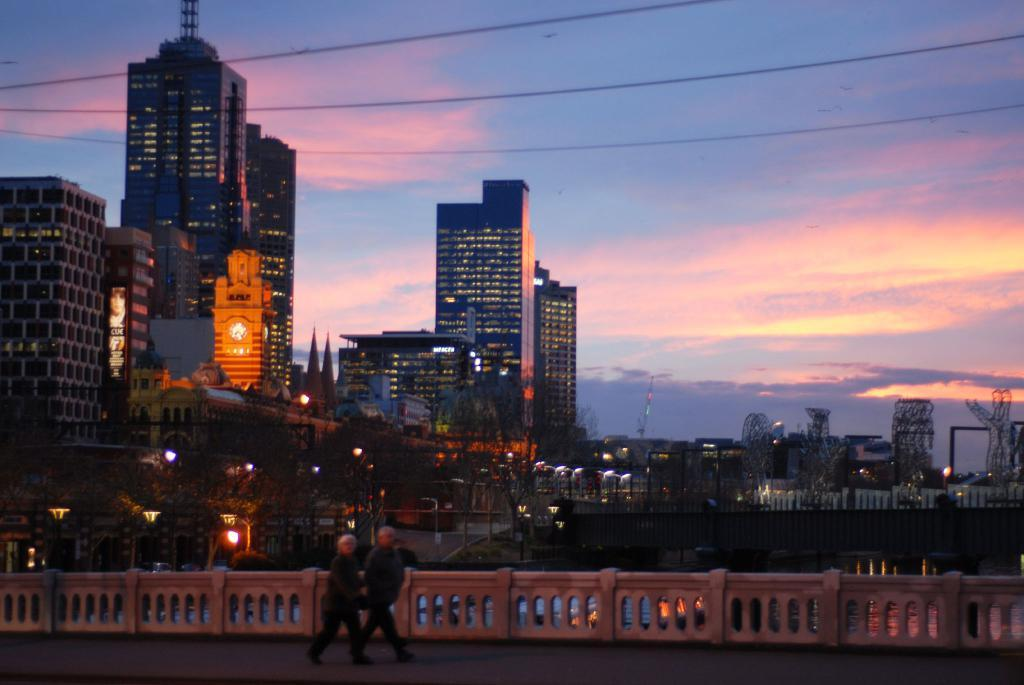What are the two people in the image doing? The two people in the image are walking. Where are they walking? They are walking on a path. What can be seen on the sides of the path? There is fencing from left to right in the image. What structures are visible in the image? There are buildings visible in the image. What is present in the image that might provide illumination? Lights are present in the image. What is visible on top of the image? Wires are visible on top in the image. How would you describe the weather based on the image? The sky is cloudy in the image. What type of plastic is being used to play the drum in the image? There is no drum or plastic present in the image. What word is being spelled out by the lights in the image? The lights in the image do not form a word; they are simply present for illumination. 